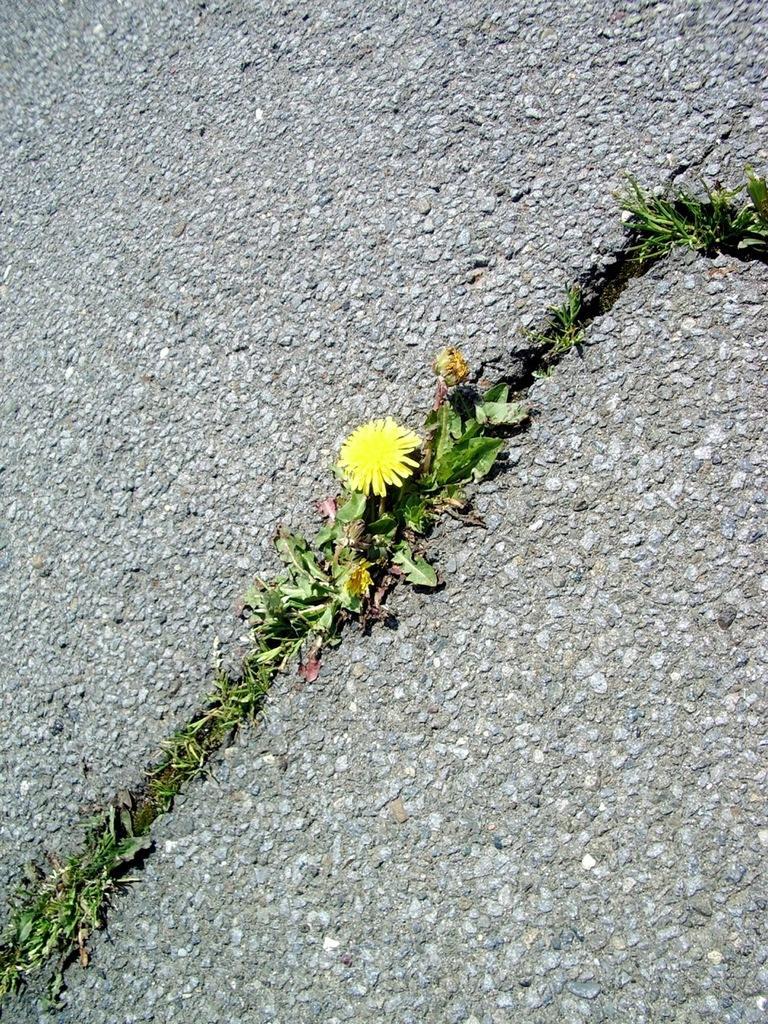How would you summarize this image in a sentence or two? In the center of the image we can see a flower, which is in yellow color and there are leaves. In the background there is a road. 